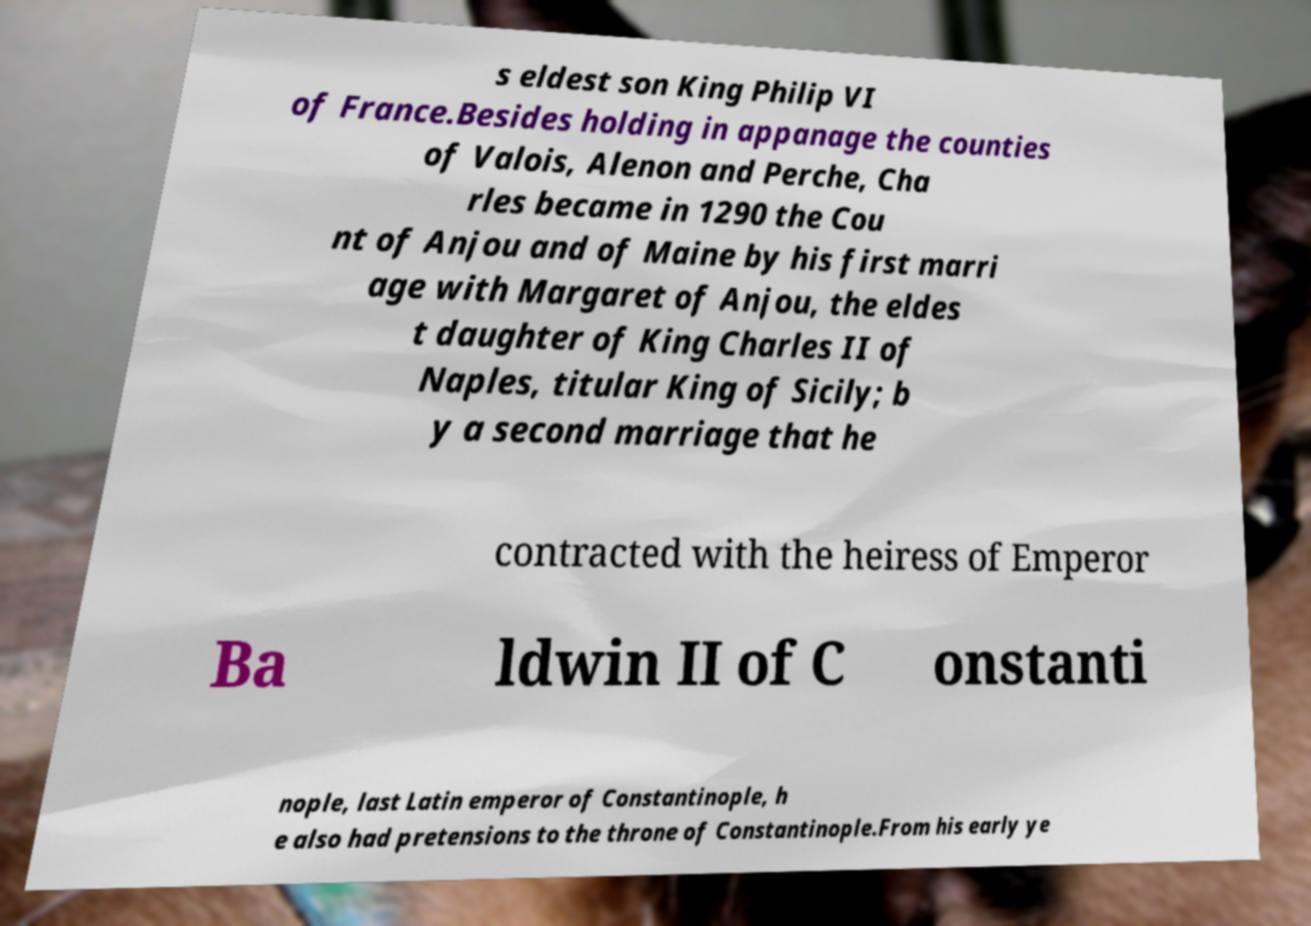There's text embedded in this image that I need extracted. Can you transcribe it verbatim? s eldest son King Philip VI of France.Besides holding in appanage the counties of Valois, Alenon and Perche, Cha rles became in 1290 the Cou nt of Anjou and of Maine by his first marri age with Margaret of Anjou, the eldes t daughter of King Charles II of Naples, titular King of Sicily; b y a second marriage that he contracted with the heiress of Emperor Ba ldwin II of C onstanti nople, last Latin emperor of Constantinople, h e also had pretensions to the throne of Constantinople.From his early ye 